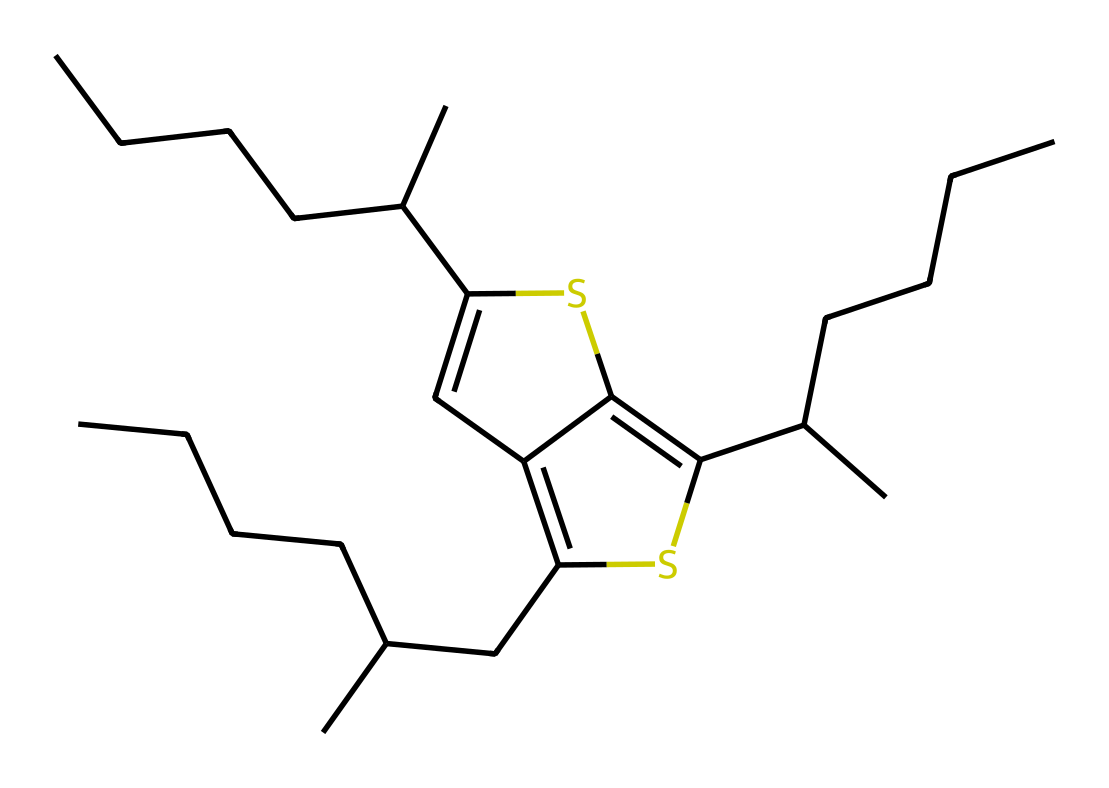What is the main functional group present in this polymer? The polymer structure contains a thiophene ring denoting the presence of a sulfur atom as part of a heterocyclic compound, which is characteristic of conductive polymers.
Answer: thiophene How many carbon atoms are in the chemical structure? Analyzing the SMILES representation, we can count a total of 24 carbon atoms present in the entire chemical structure.
Answer: 24 What type of bonds are prevalent in the structure? The structure contains a combination of single C-C bonds, as well as double C=C bonds, which are characteristic of polymer backbones contributing to electrical conductivity.
Answer: single and double bonds What property is associated with the π-conjugation in this polymer? The presence of π-conjugation in the polymer, due to the alternating double bonds, allows for delocalized electrons which results in enhanced electrical conductivity.
Answer: electrical conductivity Does this polymer have a branched or linear structure? The SMILES notation indicates multiple branching points in the structure due to the presence of isopropyl groups and other branching regions in the carbon chain.
Answer: branched 